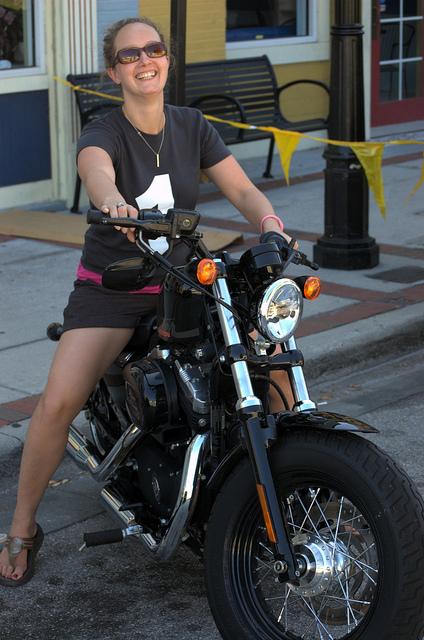What safety device should this woman be wearing on her head?
Be succinct. Helmet. What color are the tires?
Quick response, please. Black. What is covering the woman's eyes?
Give a very brief answer. Sunglasses. What color is the woman's belt?
Concise answer only. Pink. 